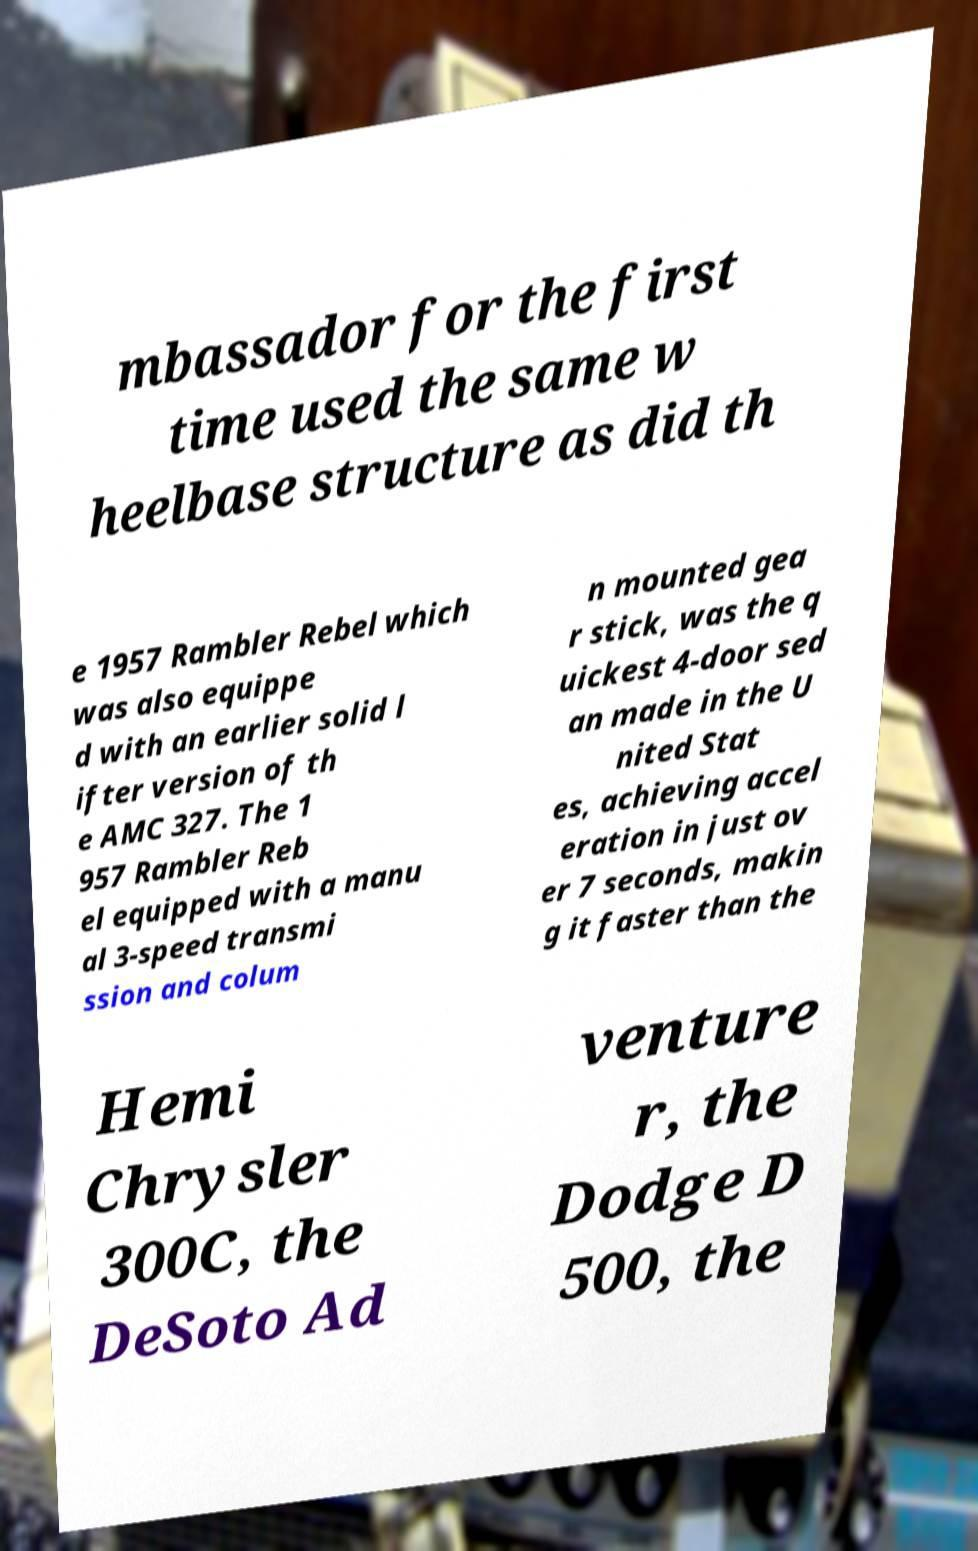Could you assist in decoding the text presented in this image and type it out clearly? mbassador for the first time used the same w heelbase structure as did th e 1957 Rambler Rebel which was also equippe d with an earlier solid l ifter version of th e AMC 327. The 1 957 Rambler Reb el equipped with a manu al 3-speed transmi ssion and colum n mounted gea r stick, was the q uickest 4-door sed an made in the U nited Stat es, achieving accel eration in just ov er 7 seconds, makin g it faster than the Hemi Chrysler 300C, the DeSoto Ad venture r, the Dodge D 500, the 